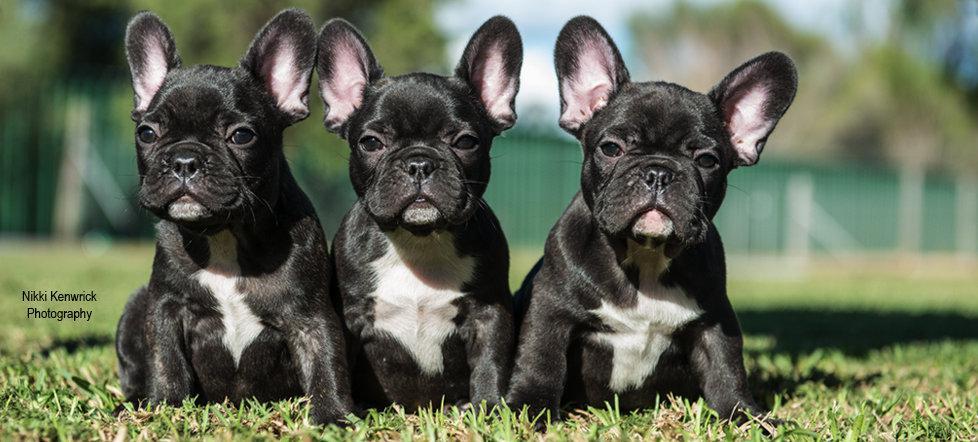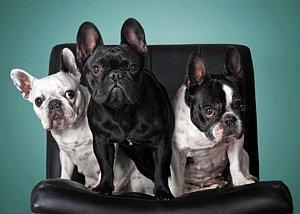The first image is the image on the left, the second image is the image on the right. Assess this claim about the two images: "Exactly six little dogs are shown.". Correct or not? Answer yes or no. Yes. The first image is the image on the left, the second image is the image on the right. Given the left and right images, does the statement "There are six dogs" hold true? Answer yes or no. Yes. 